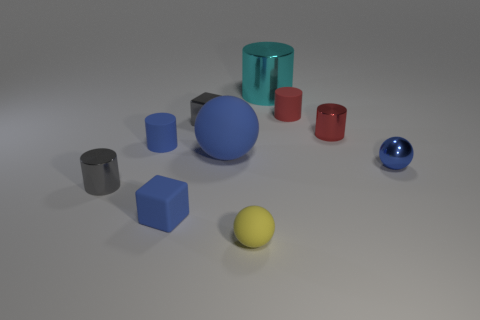Subtract all blue cylinders. How many cylinders are left? 4 Subtract all small red metallic cylinders. How many cylinders are left? 4 Subtract all green cylinders. Subtract all cyan cubes. How many cylinders are left? 5 Subtract all balls. How many objects are left? 7 Add 4 blue matte objects. How many blue matte objects are left? 7 Add 2 tiny red shiny cylinders. How many tiny red shiny cylinders exist? 3 Subtract 0 cyan blocks. How many objects are left? 10 Subtract all cylinders. Subtract all small blue matte cylinders. How many objects are left? 4 